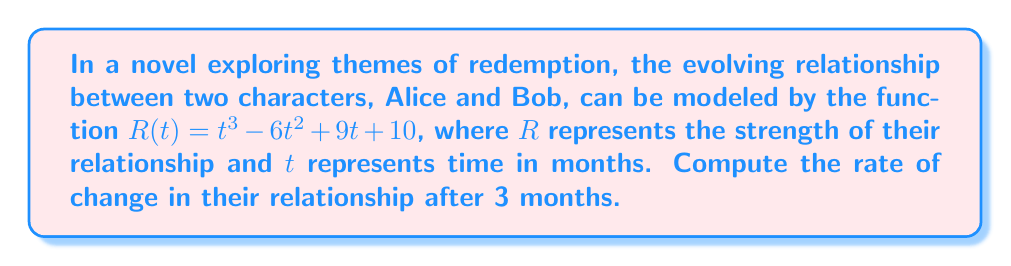Can you answer this question? To find the rate of change in the relationship after 3 months, we need to:

1. Find the derivative of the function $R(t)$.
2. Evaluate the derivative at $t = 3$.

Step 1: Compute the derivative of $R(t)$

$$\begin{align}
R(t) &= t^3 - 6t^2 + 9t + 10 \\
R'(t) &= 3t^2 - 12t + 9
\end{align}$$

We use the power rule for $t^3$ and $t^2$, and the constant rule for the linear and constant terms.

Step 2: Evaluate $R'(t)$ at $t = 3$

$$\begin{align}
R'(3) &= 3(3^2) - 12(3) + 9 \\
&= 3(9) - 36 + 9 \\
&= 27 - 36 + 9 \\
&= 0
\end{align}$$

The rate of change in their relationship after 3 months is 0, indicating a turning point in their relationship's development. This could represent a moment of equilibrium or transition in their journey of redemption.
Answer: $0$ 